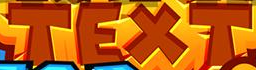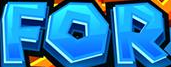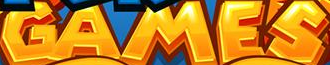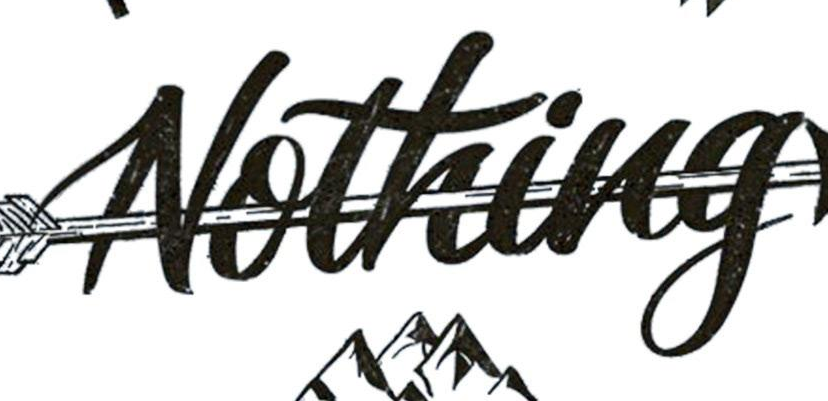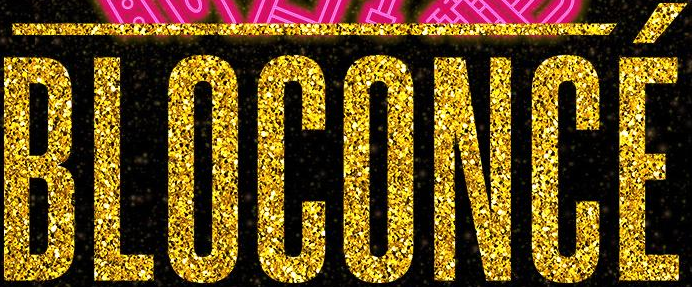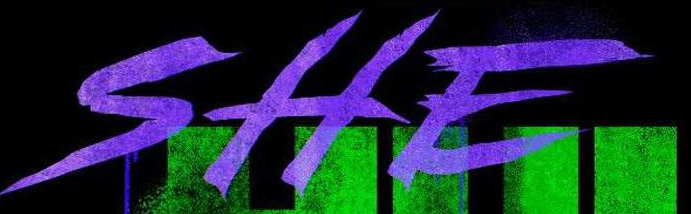What text is displayed in these images sequentially, separated by a semicolon? TEXT; FOR; GAMES; Nothing; BLOCONCÉ; SHE 